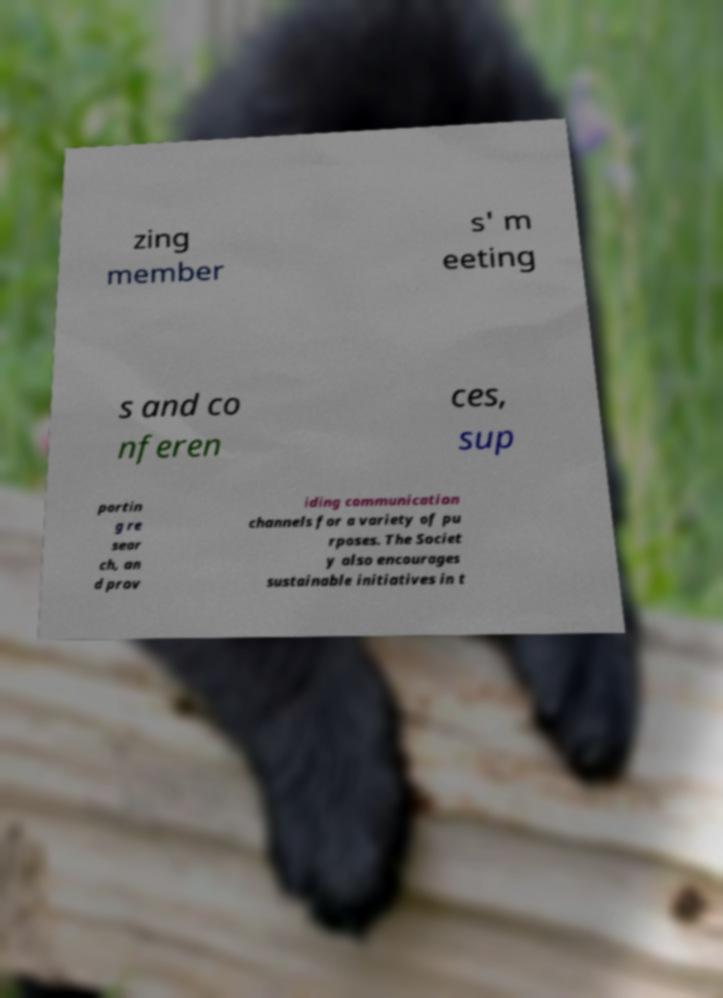What messages or text are displayed in this image? I need them in a readable, typed format. zing member s' m eeting s and co nferen ces, sup portin g re sear ch, an d prov iding communication channels for a variety of pu rposes. The Societ y also encourages sustainable initiatives in t 